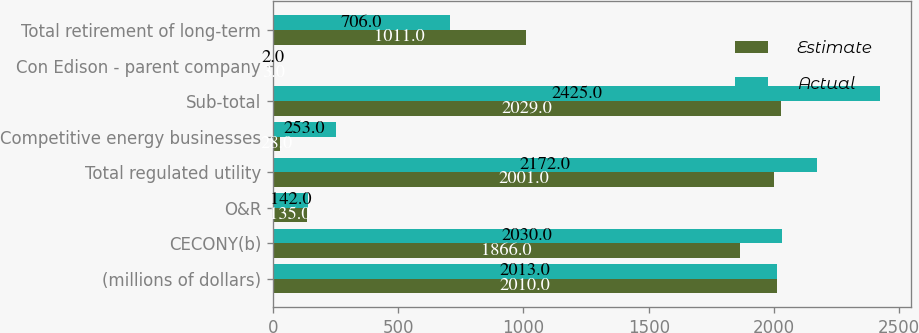Convert chart to OTSL. <chart><loc_0><loc_0><loc_500><loc_500><stacked_bar_chart><ecel><fcel>(millions of dollars)<fcel>CECONY(b)<fcel>O&R<fcel>Total regulated utility<fcel>Competitive energy businesses<fcel>Sub-total<fcel>Con Edison - parent company<fcel>Total retirement of long-term<nl><fcel>Estimate<fcel>2010<fcel>1866<fcel>135<fcel>2001<fcel>28<fcel>2029<fcel>3<fcel>1011<nl><fcel>Actual<fcel>2013<fcel>2030<fcel>142<fcel>2172<fcel>253<fcel>2425<fcel>2<fcel>706<nl></chart> 